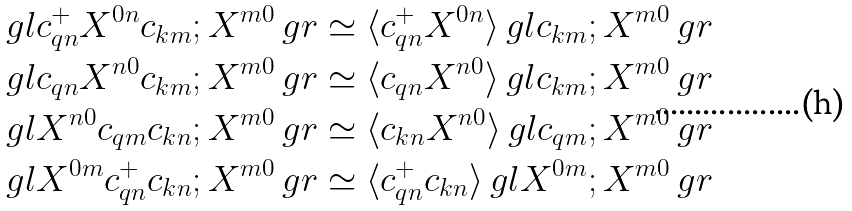<formula> <loc_0><loc_0><loc_500><loc_500>\ g l c ^ { + } _ { q n } X ^ { 0 n } c _ { k m } ; X ^ { m 0 } \ g r & \simeq \langle c ^ { + } _ { q n } X ^ { 0 n } \rangle \ g l c _ { k m } ; X ^ { m 0 } \ g r \\ \ g l c _ { q n } X ^ { n 0 } c _ { k m } ; X ^ { m 0 } \ g r & \simeq \langle c _ { q n } X ^ { n 0 } \rangle \ g l c _ { k m } ; X ^ { m 0 } \ g r \\ \ g l X ^ { n 0 } c _ { q m } c _ { k n } ; X ^ { m 0 } \ g r & \simeq \langle c _ { k n } X ^ { n 0 } \rangle \ g l c _ { q m } ; X ^ { m 0 } \ g r \\ \ g l X ^ { 0 m } c ^ { + } _ { q n } c _ { k n } ; X ^ { m 0 } \ g r & \simeq \langle c ^ { + } _ { q n } c _ { k n } \rangle \ g l X ^ { 0 m } ; X ^ { m 0 } \ g r</formula> 